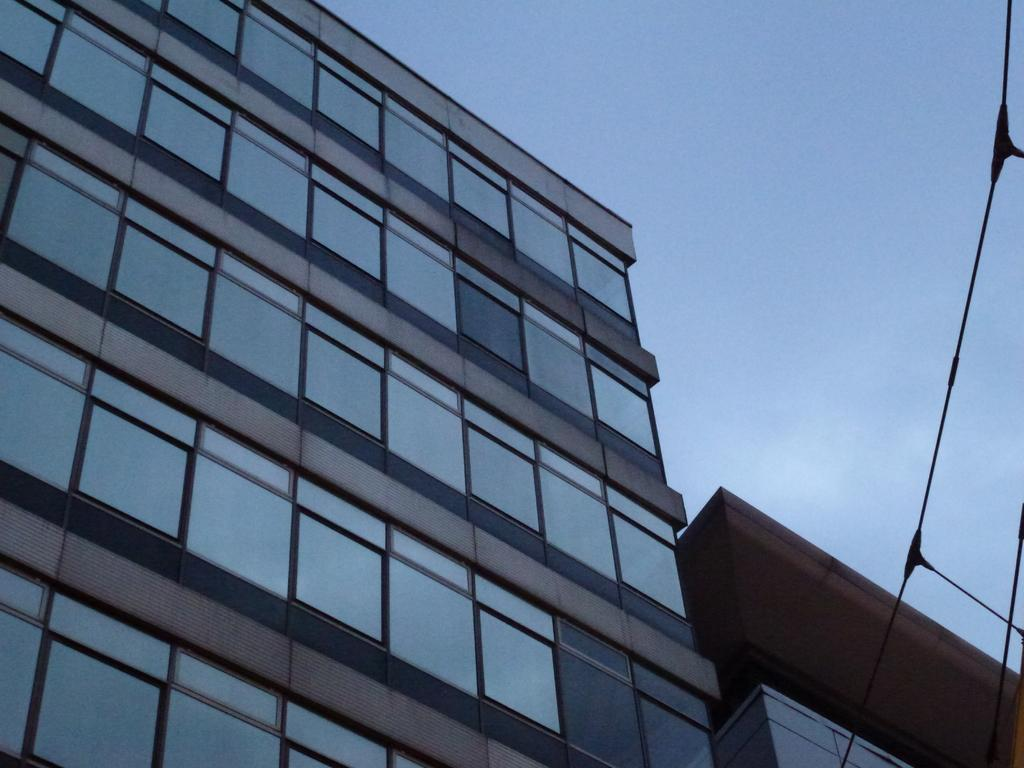What structure is located on the left side of the image? There is a building on the left side of the image. What can be seen in the background of the image? The sky is visible in the background of the image. What type of treatment is being administered to the deer in the image? There is no deer present in the image, so no treatment can be administered. What color is the ink used to write on the building in the image? There is no writing or ink visible on the building in the image. 